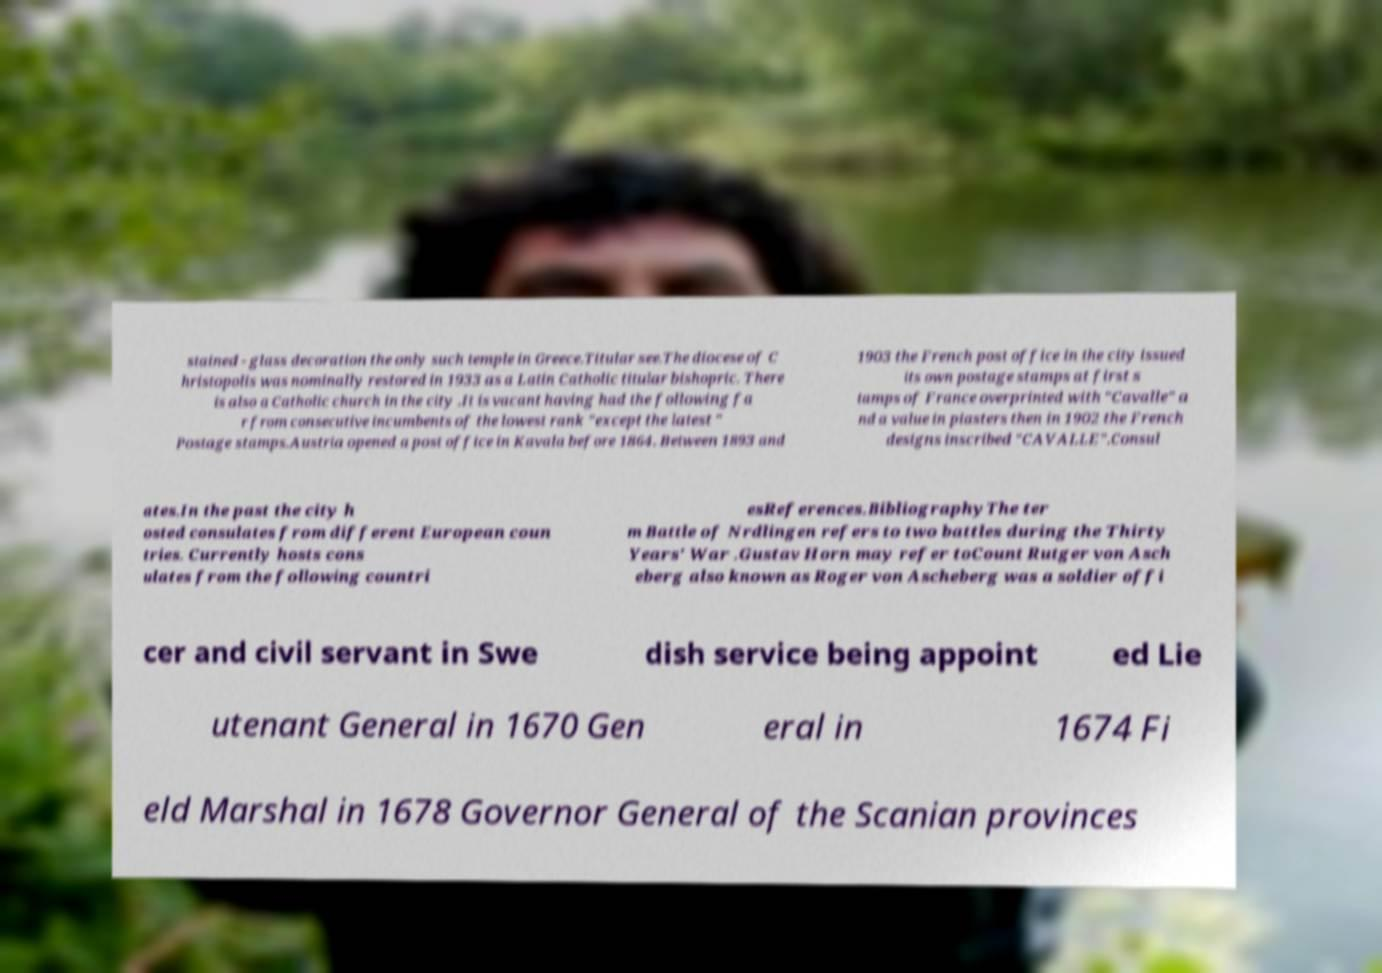What messages or text are displayed in this image? I need them in a readable, typed format. stained - glass decoration the only such temple in Greece.Titular see.The diocese of C hristopolis was nominally restored in 1933 as a Latin Catholic titular bishopric. There is also a Catholic church in the city .It is vacant having had the following fa r from consecutive incumbents of the lowest rank "except the latest " Postage stamps.Austria opened a post office in Kavala before 1864. Between 1893 and 1903 the French post office in the city issued its own postage stamps at first s tamps of France overprinted with "Cavalle" a nd a value in piasters then in 1902 the French designs inscribed "CAVALLE".Consul ates.In the past the city h osted consulates from different European coun tries. Currently hosts cons ulates from the following countri esReferences.BibliographyThe ter m Battle of Nrdlingen refers to two battles during the Thirty Years' War .Gustav Horn may refer toCount Rutger von Asch eberg also known as Roger von Ascheberg was a soldier offi cer and civil servant in Swe dish service being appoint ed Lie utenant General in 1670 Gen eral in 1674 Fi eld Marshal in 1678 Governor General of the Scanian provinces 